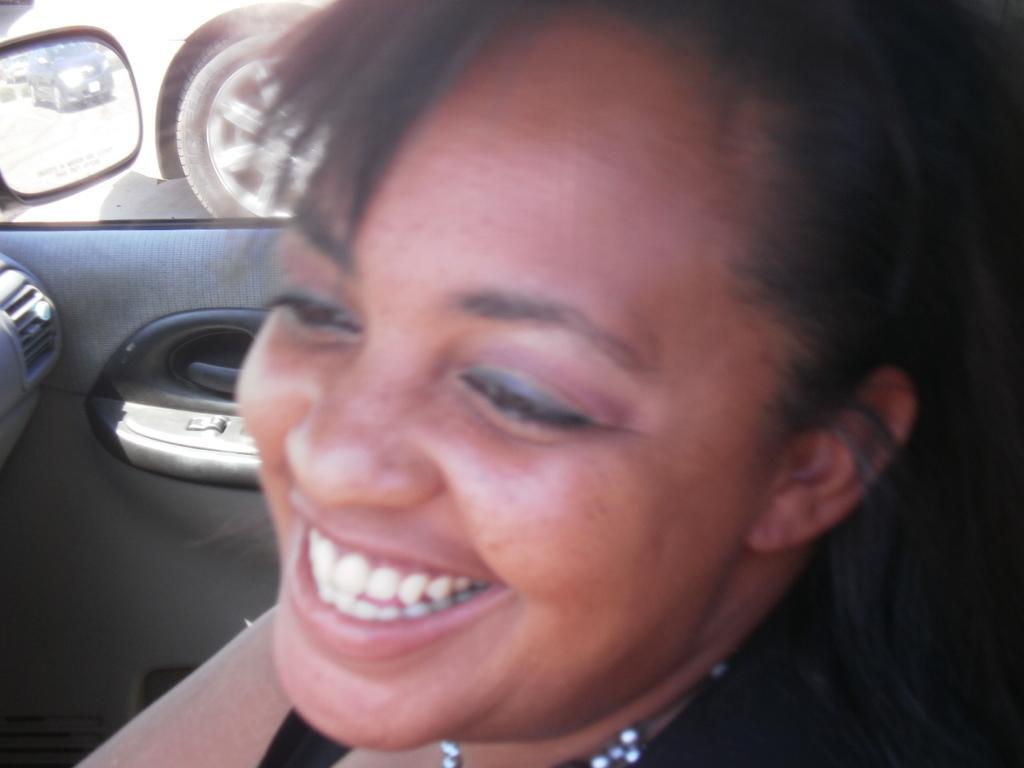How would you summarize this image in a sentence or two? In the picture I can see the face of a woman and there is a smile on her face. Looks like she is in the vehicle. I can see the mirror and the wheel of a vehicle on the top left side of the picture. 